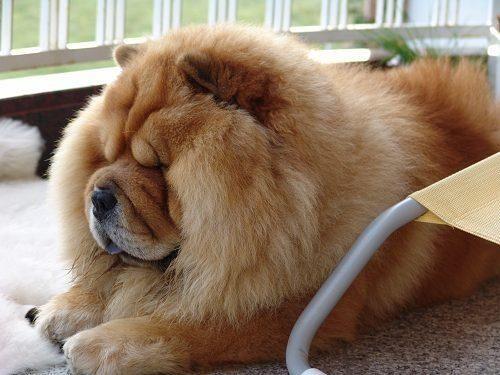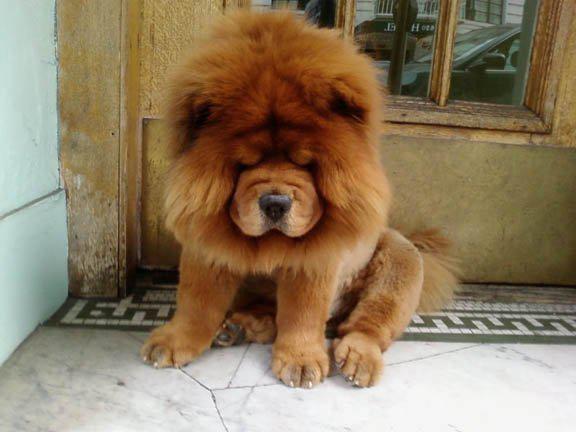The first image is the image on the left, the second image is the image on the right. For the images shown, is this caption "The combined images include two chows and one other animal figure, all are the same color, and at least two have their paws forward." true? Answer yes or no. No. The first image is the image on the left, the second image is the image on the right. For the images displayed, is the sentence "The left and right image contains the same number of dogs with at least one laying down." factually correct? Answer yes or no. Yes. 